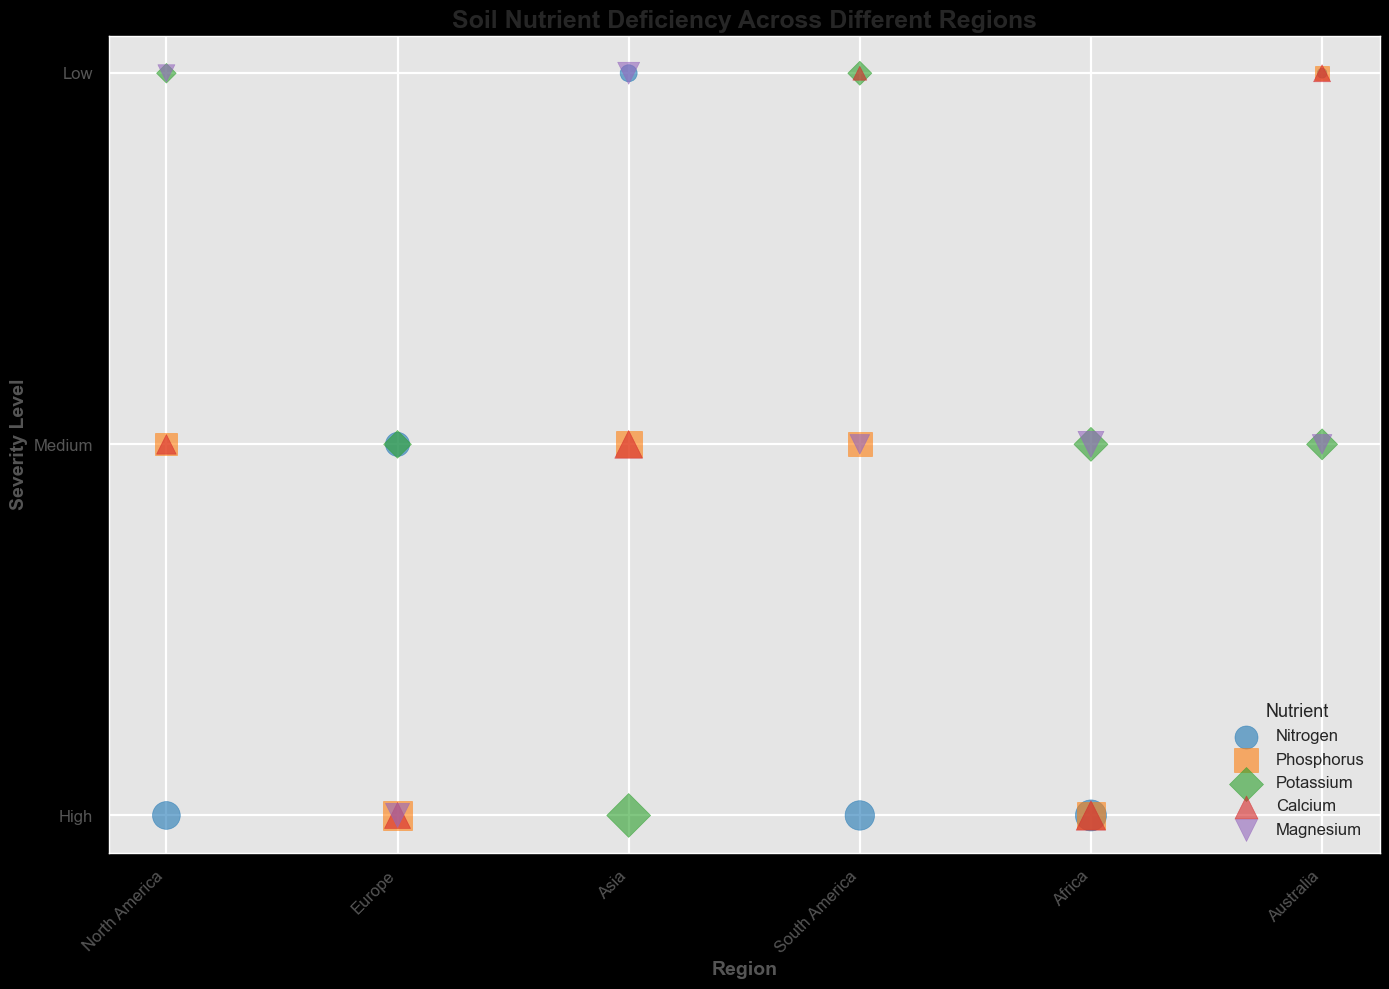What's the region with the highest severity level for Nitrogen deficiency? Look at the plot to identify the region with the highest severity level for Nitrogen by spotting the largest blue bubble along the y-axis.
Answer: Africa Which nutrient has the highest deficiency level in South America? Identify the largest bubble in the South America x-axis group. The orange square at the top has the largest size.
Answer: Nitrogen Compare the deficiency levels of Phosphorus in Africa and Asia. Which one is higher? Identify the size of the orange squares (Phosphorus) in Africa and Asia. The orange square in Africa is smaller than in Asia.
Answer: Asia What's the average deficiency level for the nutrients in Europe? Find the sizes of all bubbles in Europe, convert them back to deficiency levels, add them up, and then divide by the number of nutrients: (6 + 9 + 4 + 7 + 6) / 5 = 32 / 5 = 6.4
Answer: 6.4 Which nutrient has the highest severity level in Australia? Look for the tallest bubble in the Australia x-axis group. The green diamond at severity level 5 is the tallest.
Answer: Potassium What's the range of severity levels for Nitrogen across all regions? Find the lowest and highest severity levels for the blue circles. The lowest is 1 (Australia), and the highest is 10 (Africa). So, 1 to 10.
Answer: 1 to 10 Comparing the size of the Potassium deficiency in North America and Africa, which is greater? Compare the green diamond sizes in North America and Africa. The size in Africa is larger.
Answer: Africa Identify the region with the smallest deficiency level for Magnesium. Look for the smallest purple triangle size. The smallest is in Asia.
Answer: Asia What is the total deficiency level for Nitrogen and Potassium in Asia? Add the deficiency levels of Nitrogen (3) and Potassium (10) in Asia: 3 + 10 = 13.
Answer: 13 